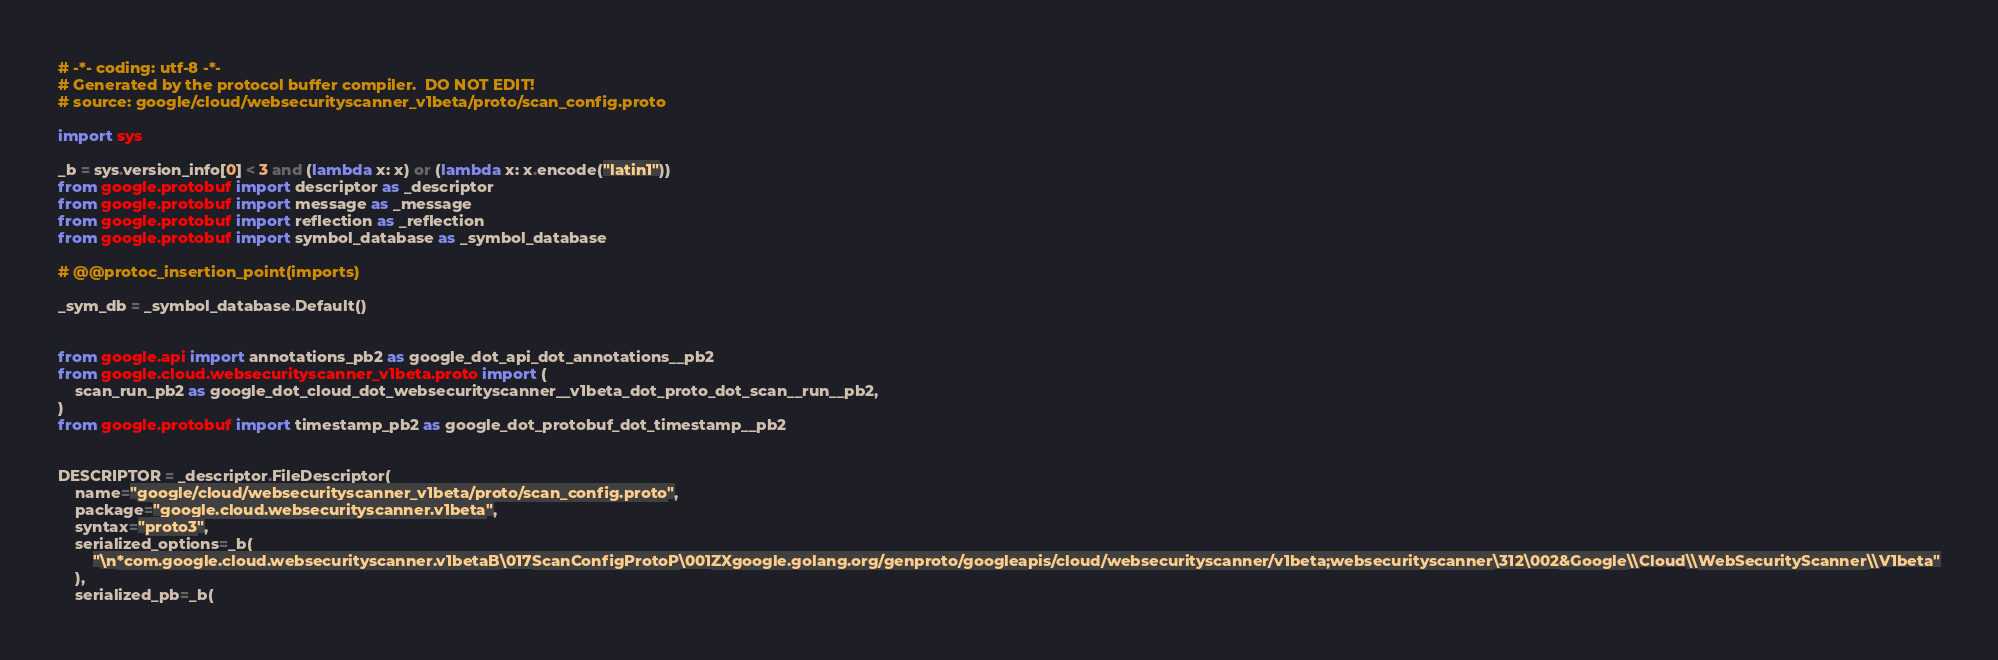Convert code to text. <code><loc_0><loc_0><loc_500><loc_500><_Python_># -*- coding: utf-8 -*-
# Generated by the protocol buffer compiler.  DO NOT EDIT!
# source: google/cloud/websecurityscanner_v1beta/proto/scan_config.proto

import sys

_b = sys.version_info[0] < 3 and (lambda x: x) or (lambda x: x.encode("latin1"))
from google.protobuf import descriptor as _descriptor
from google.protobuf import message as _message
from google.protobuf import reflection as _reflection
from google.protobuf import symbol_database as _symbol_database

# @@protoc_insertion_point(imports)

_sym_db = _symbol_database.Default()


from google.api import annotations_pb2 as google_dot_api_dot_annotations__pb2
from google.cloud.websecurityscanner_v1beta.proto import (
    scan_run_pb2 as google_dot_cloud_dot_websecurityscanner__v1beta_dot_proto_dot_scan__run__pb2,
)
from google.protobuf import timestamp_pb2 as google_dot_protobuf_dot_timestamp__pb2


DESCRIPTOR = _descriptor.FileDescriptor(
    name="google/cloud/websecurityscanner_v1beta/proto/scan_config.proto",
    package="google.cloud.websecurityscanner.v1beta",
    syntax="proto3",
    serialized_options=_b(
        "\n*com.google.cloud.websecurityscanner.v1betaB\017ScanConfigProtoP\001ZXgoogle.golang.org/genproto/googleapis/cloud/websecurityscanner/v1beta;websecurityscanner\312\002&Google\\Cloud\\WebSecurityScanner\\V1beta"
    ),
    serialized_pb=_b(</code> 